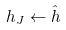Convert formula to latex. <formula><loc_0><loc_0><loc_500><loc_500>h _ { J } \leftarrow \hat { h }</formula> 